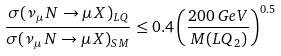Convert formula to latex. <formula><loc_0><loc_0><loc_500><loc_500>\frac { \sigma ( \nu _ { \mu } \, N \rightarrow \mu \, X ) _ { L Q } } { \sigma ( \nu _ { \mu } \, N \rightarrow \mu \, X ) _ { S M } } \leq 0 . 4 \left ( \frac { 2 0 0 \, G e V } { M ( L Q _ { 2 } ) } \right ) ^ { 0 . 5 }</formula> 